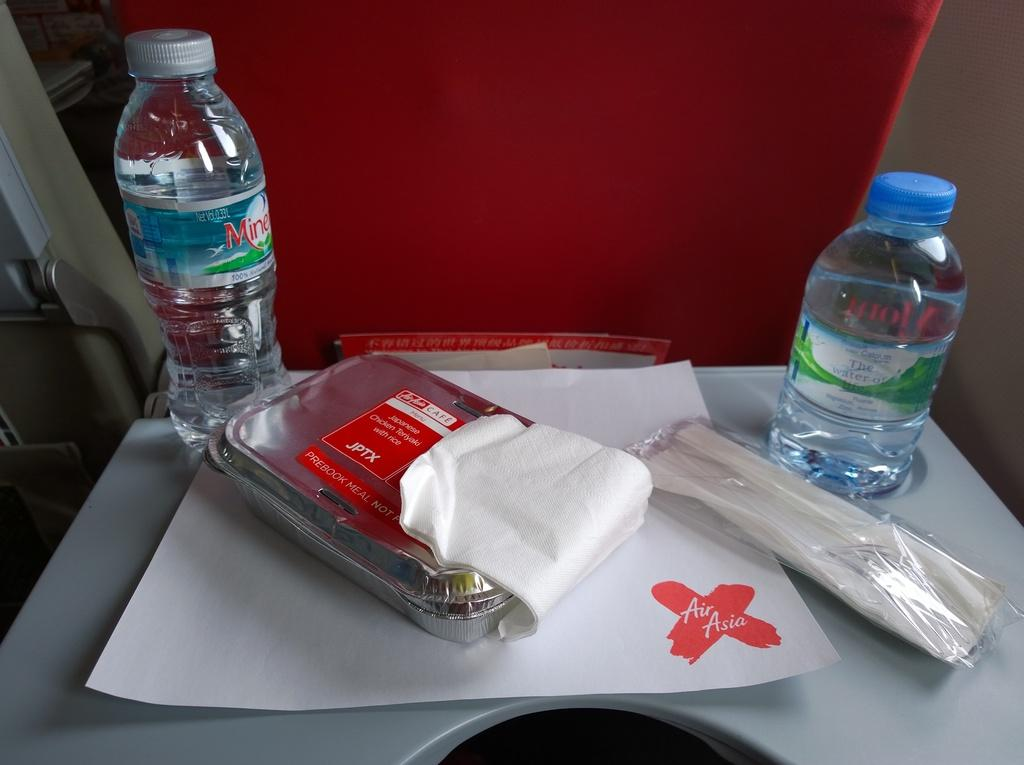What is placed on the table in the image? There is a paper and a food box on the table. Are there any containers on the table? Yes, there is a food box on the table. What else can be seen on the table besides the paper and food box? There are bottles on the table. How many ducks are swimming in the bottles in the image? There are no ducks present in the image, and the bottles do not contain any water for ducks to swim in. 